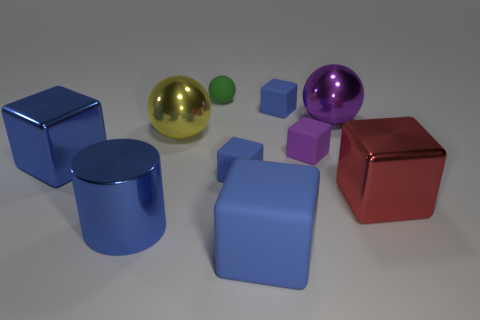There is a metallic sphere to the left of the tiny purple cube; what color is it?
Provide a succinct answer. Yellow. There is a yellow object that is the same shape as the small green rubber object; what size is it?
Your response must be concise. Large. What number of things are large shiny things that are behind the red block or things right of the tiny green sphere?
Offer a terse response. 8. What is the size of the metallic object that is both on the left side of the green thing and right of the shiny cylinder?
Make the answer very short. Large. There is a green rubber object; does it have the same shape as the large blue shiny object behind the big red object?
Keep it short and to the point. No. What number of things are either cubes left of the red metallic block or small yellow shiny balls?
Offer a very short reply. 5. Are the red cube and the big cube behind the red thing made of the same material?
Give a very brief answer. Yes. There is a big blue metallic thing that is in front of the shiny cube that is right of the big blue shiny cube; what shape is it?
Provide a succinct answer. Cylinder. Do the shiny cylinder and the shiny block left of the big blue matte thing have the same color?
Your answer should be compact. Yes. The tiny green object is what shape?
Give a very brief answer. Sphere. 